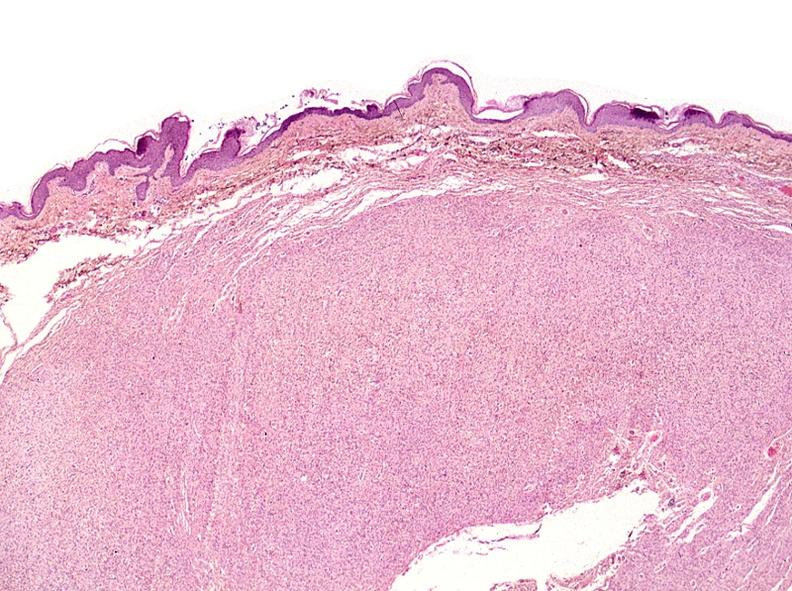where is this?
Answer the question using a single word or phrase. Skin 